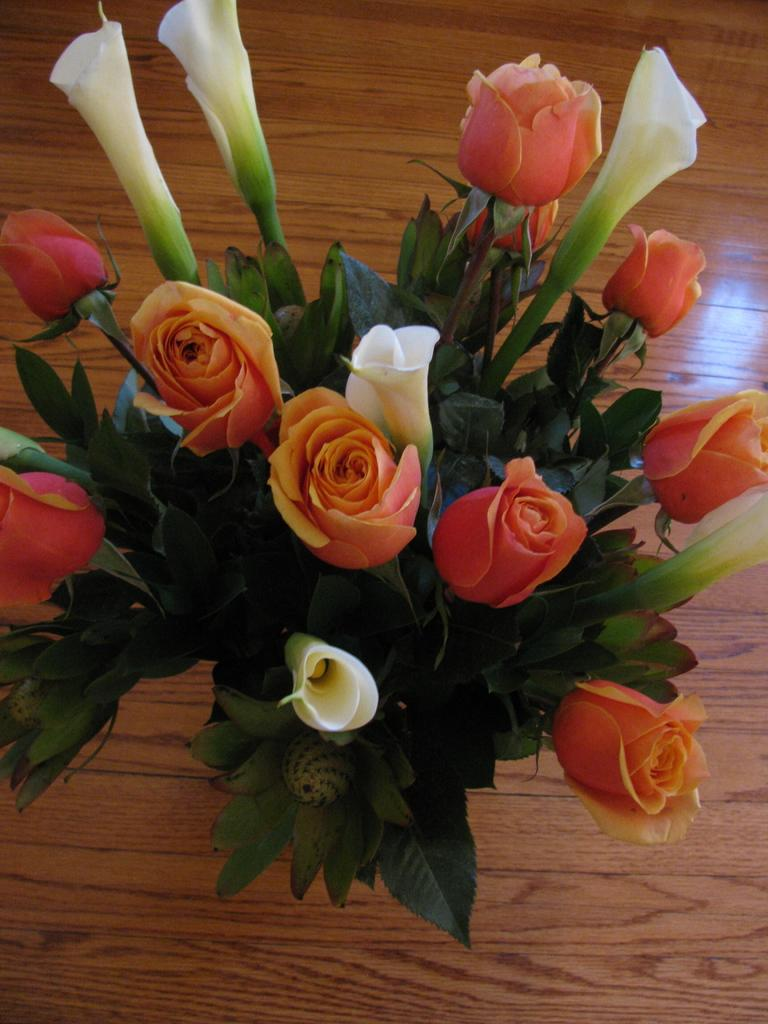What type of plant life can be seen in the image? There are flowers and leaves in the image. What material is the surface visible in the background of the image made of? The surface visible in the background of the image is made of wood. What type of mint can be seen growing among the flowers in the image? There is no mint present in the image; it only features flowers and leaves. 